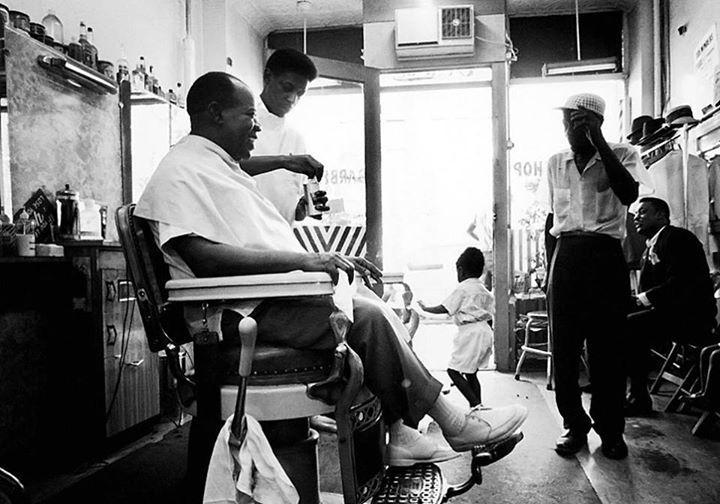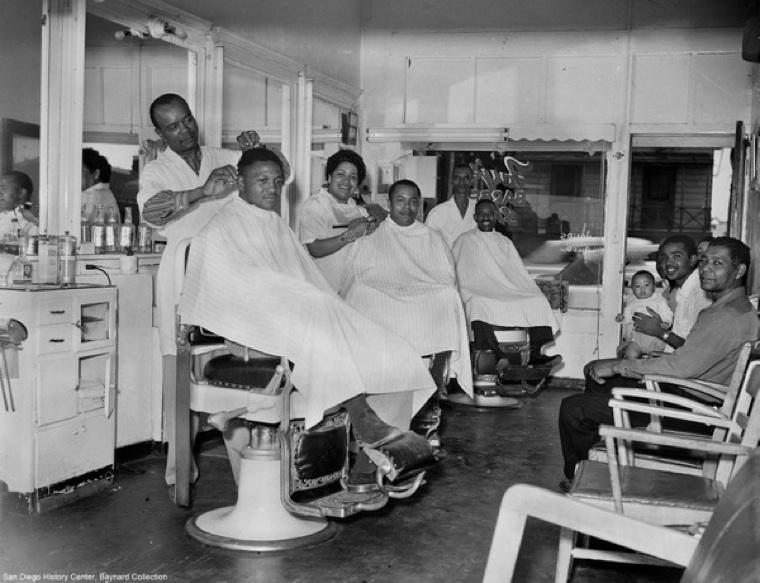The first image is the image on the left, the second image is the image on the right. Analyze the images presented: Is the assertion "the picture i=on the left is in color" valid? Answer yes or no. No. The first image is the image on the left, the second image is the image on the right. For the images shown, is this caption "In each image, there is more than one person sitting down." true? Answer yes or no. Yes. 